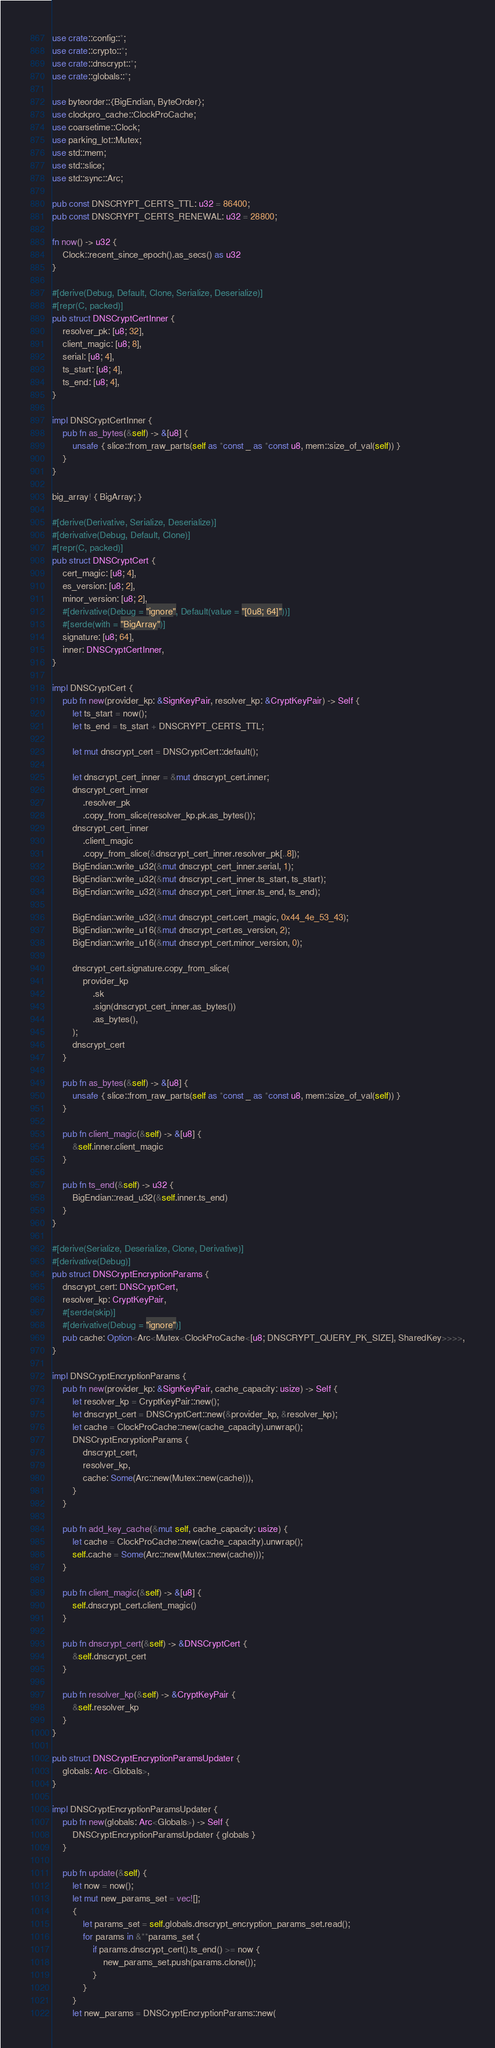<code> <loc_0><loc_0><loc_500><loc_500><_Rust_>use crate::config::*;
use crate::crypto::*;
use crate::dnscrypt::*;
use crate::globals::*;

use byteorder::{BigEndian, ByteOrder};
use clockpro_cache::ClockProCache;
use coarsetime::Clock;
use parking_lot::Mutex;
use std::mem;
use std::slice;
use std::sync::Arc;

pub const DNSCRYPT_CERTS_TTL: u32 = 86400;
pub const DNSCRYPT_CERTS_RENEWAL: u32 = 28800;

fn now() -> u32 {
    Clock::recent_since_epoch().as_secs() as u32
}

#[derive(Debug, Default, Clone, Serialize, Deserialize)]
#[repr(C, packed)]
pub struct DNSCryptCertInner {
    resolver_pk: [u8; 32],
    client_magic: [u8; 8],
    serial: [u8; 4],
    ts_start: [u8; 4],
    ts_end: [u8; 4],
}

impl DNSCryptCertInner {
    pub fn as_bytes(&self) -> &[u8] {
        unsafe { slice::from_raw_parts(self as *const _ as *const u8, mem::size_of_val(self)) }
    }
}

big_array! { BigArray; }

#[derive(Derivative, Serialize, Deserialize)]
#[derivative(Debug, Default, Clone)]
#[repr(C, packed)]
pub struct DNSCryptCert {
    cert_magic: [u8; 4],
    es_version: [u8; 2],
    minor_version: [u8; 2],
    #[derivative(Debug = "ignore", Default(value = "[0u8; 64]"))]
    #[serde(with = "BigArray")]
    signature: [u8; 64],
    inner: DNSCryptCertInner,
}

impl DNSCryptCert {
    pub fn new(provider_kp: &SignKeyPair, resolver_kp: &CryptKeyPair) -> Self {
        let ts_start = now();
        let ts_end = ts_start + DNSCRYPT_CERTS_TTL;

        let mut dnscrypt_cert = DNSCryptCert::default();

        let dnscrypt_cert_inner = &mut dnscrypt_cert.inner;
        dnscrypt_cert_inner
            .resolver_pk
            .copy_from_slice(resolver_kp.pk.as_bytes());
        dnscrypt_cert_inner
            .client_magic
            .copy_from_slice(&dnscrypt_cert_inner.resolver_pk[..8]);
        BigEndian::write_u32(&mut dnscrypt_cert_inner.serial, 1);
        BigEndian::write_u32(&mut dnscrypt_cert_inner.ts_start, ts_start);
        BigEndian::write_u32(&mut dnscrypt_cert_inner.ts_end, ts_end);

        BigEndian::write_u32(&mut dnscrypt_cert.cert_magic, 0x44_4e_53_43);
        BigEndian::write_u16(&mut dnscrypt_cert.es_version, 2);
        BigEndian::write_u16(&mut dnscrypt_cert.minor_version, 0);

        dnscrypt_cert.signature.copy_from_slice(
            provider_kp
                .sk
                .sign(dnscrypt_cert_inner.as_bytes())
                .as_bytes(),
        );
        dnscrypt_cert
    }

    pub fn as_bytes(&self) -> &[u8] {
        unsafe { slice::from_raw_parts(self as *const _ as *const u8, mem::size_of_val(self)) }
    }

    pub fn client_magic(&self) -> &[u8] {
        &self.inner.client_magic
    }

    pub fn ts_end(&self) -> u32 {
        BigEndian::read_u32(&self.inner.ts_end)
    }
}

#[derive(Serialize, Deserialize, Clone, Derivative)]
#[derivative(Debug)]
pub struct DNSCryptEncryptionParams {
    dnscrypt_cert: DNSCryptCert,
    resolver_kp: CryptKeyPair,
    #[serde(skip)]
    #[derivative(Debug = "ignore")]
    pub cache: Option<Arc<Mutex<ClockProCache<[u8; DNSCRYPT_QUERY_PK_SIZE], SharedKey>>>>,
}

impl DNSCryptEncryptionParams {
    pub fn new(provider_kp: &SignKeyPair, cache_capacity: usize) -> Self {
        let resolver_kp = CryptKeyPair::new();
        let dnscrypt_cert = DNSCryptCert::new(&provider_kp, &resolver_kp);
        let cache = ClockProCache::new(cache_capacity).unwrap();
        DNSCryptEncryptionParams {
            dnscrypt_cert,
            resolver_kp,
            cache: Some(Arc::new(Mutex::new(cache))),
        }
    }

    pub fn add_key_cache(&mut self, cache_capacity: usize) {
        let cache = ClockProCache::new(cache_capacity).unwrap();
        self.cache = Some(Arc::new(Mutex::new(cache)));
    }

    pub fn client_magic(&self) -> &[u8] {
        self.dnscrypt_cert.client_magic()
    }

    pub fn dnscrypt_cert(&self) -> &DNSCryptCert {
        &self.dnscrypt_cert
    }

    pub fn resolver_kp(&self) -> &CryptKeyPair {
        &self.resolver_kp
    }
}

pub struct DNSCryptEncryptionParamsUpdater {
    globals: Arc<Globals>,
}

impl DNSCryptEncryptionParamsUpdater {
    pub fn new(globals: Arc<Globals>) -> Self {
        DNSCryptEncryptionParamsUpdater { globals }
    }

    pub fn update(&self) {
        let now = now();
        let mut new_params_set = vec![];
        {
            let params_set = self.globals.dnscrypt_encryption_params_set.read();
            for params in &**params_set {
                if params.dnscrypt_cert().ts_end() >= now {
                    new_params_set.push(params.clone());
                }
            }
        }
        let new_params = DNSCryptEncryptionParams::new(</code> 